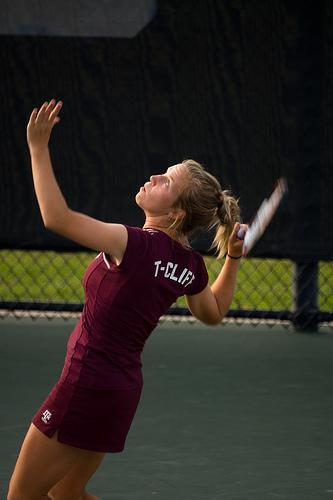Question: how is the girl positioned?
Choices:
A. Kneeling.
B. Lying down.
C. Sitting.
D. Standing.
Answer with the letter. Answer: D Question: what is the woman doing?
Choices:
A. Play tennis.
B. Golfing.
C. Running.
D. Playing softball.
Answer with the letter. Answer: A Question: where is the tennis racquet?
Choices:
A. On the bench.
B. In the bag.
C. In the girls hand.
D. On the ground.
Answer with the letter. Answer: C 